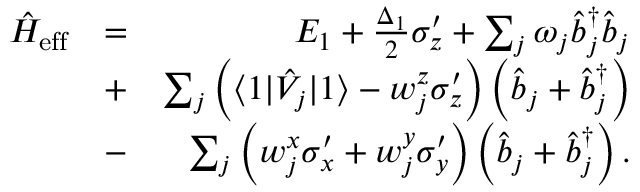<formula> <loc_0><loc_0><loc_500><loc_500>\begin{array} { r l r } { \hat { H } _ { e f f } } & { = } & { E _ { 1 } + \frac { \Delta _ { 1 } } { 2 } \sigma _ { z } ^ { \prime } + \sum _ { j } \omega _ { j } \hat { b } _ { j } ^ { \dagger } \hat { b } _ { j } } \\ & { + } & { \sum _ { j } \left ( \langle 1 | \hat { V } _ { j } | 1 \rangle - w _ { j } ^ { z } \sigma _ { z } ^ { \prime } \right ) \left ( \hat { b } _ { j } + \hat { b } _ { j } ^ { \dagger } \right ) } \\ & { - } & { \sum _ { j } \left ( w _ { j } ^ { x } \sigma _ { x } ^ { \prime } + w _ { j } ^ { y } \sigma _ { y } ^ { \prime } \right ) \left ( \hat { b } _ { j } + \hat { b } _ { j } ^ { \dagger } \right ) . } \end{array}</formula> 